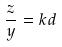Convert formula to latex. <formula><loc_0><loc_0><loc_500><loc_500>\frac { z } { y } = k d</formula> 